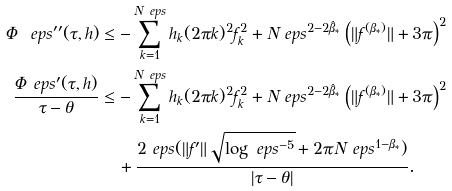Convert formula to latex. <formula><loc_0><loc_0><loc_500><loc_500>\Phi _ { \ } e p s ^ { \prime \prime } ( \tau , h ) & \leq - \sum _ { k = 1 } ^ { N _ { \ } e p s } h _ { k } ( 2 \pi k ) ^ { 2 } f _ { k } ^ { 2 } + N _ { \ } e p s ^ { 2 - 2 \hat { \beta } _ { * } } \left ( \| f ^ { ( \beta _ { * } ) } \| + 3 \pi \right ) ^ { 2 } \\ \frac { \Phi _ { \ } e p s ^ { \prime } ( \tau , h ) } { \tau - \theta } & \leq - \sum _ { k = 1 } ^ { N _ { \ } e p s } h _ { k } ( 2 \pi k ) ^ { 2 } f _ { k } ^ { 2 } + N _ { \ } e p s ^ { 2 - 2 \hat { \beta } _ { * } } \left ( \| f ^ { ( \beta _ { * } ) } \| + 3 \pi \right ) ^ { 2 } \\ & \quad + \frac { 2 \ e p s ( \| f ^ { \prime } \| \sqrt { \log \ e p s ^ { - 5 } } + 2 \pi N _ { \ } e p s ^ { 1 - \beta _ { * } } ) } { | \tau - \theta | } .</formula> 